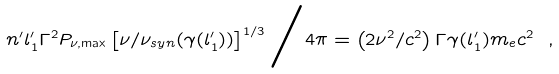Convert formula to latex. <formula><loc_0><loc_0><loc_500><loc_500>n ^ { \prime } l ^ { \prime } _ { 1 } \Gamma ^ { 2 } P _ { \nu , \max } \left [ \nu / \nu _ { s y n } ( \gamma ( l ^ { \prime } _ { 1 } ) ) \right ] ^ { 1 / 3 } { \Big / } 4 \pi = \left ( 2 \nu ^ { 2 } / c ^ { 2 } \right ) \Gamma \gamma ( l ^ { \prime } _ { 1 } ) m _ { e } c ^ { 2 } \ ,</formula> 